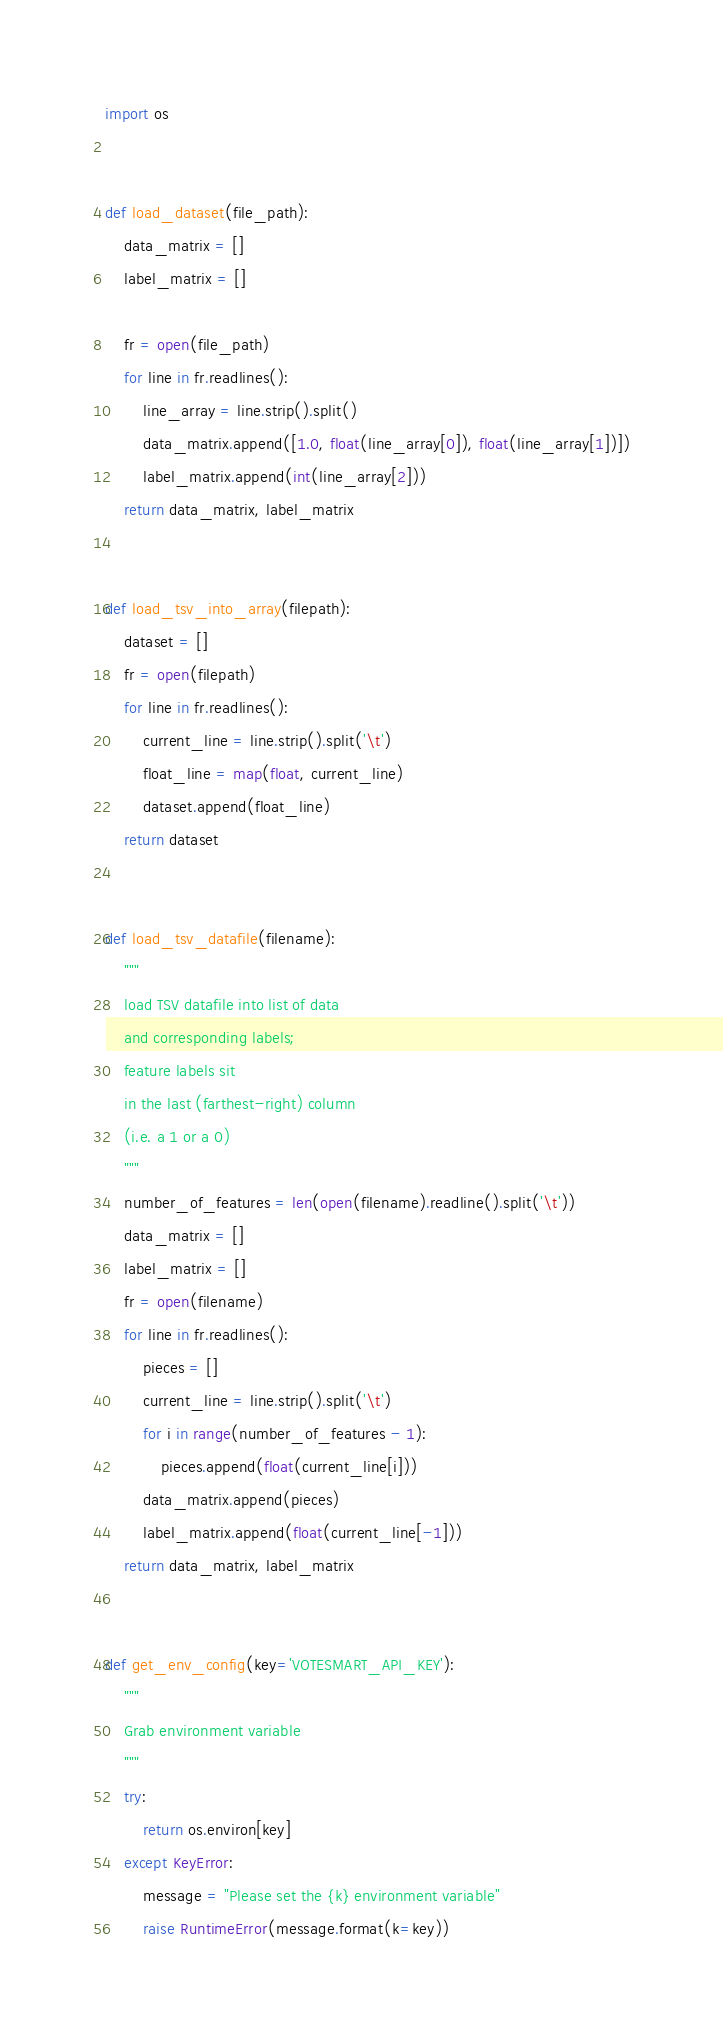Convert code to text. <code><loc_0><loc_0><loc_500><loc_500><_Python_>import os


def load_dataset(file_path):
    data_matrix = []
    label_matrix = []

    fr = open(file_path)
    for line in fr.readlines():
        line_array = line.strip().split()
        data_matrix.append([1.0, float(line_array[0]), float(line_array[1])])
        label_matrix.append(int(line_array[2]))
    return data_matrix, label_matrix


def load_tsv_into_array(filepath):
    dataset = []
    fr = open(filepath)
    for line in fr.readlines():
        current_line = line.strip().split('\t')
        float_line = map(float, current_line)
        dataset.append(float_line)
    return dataset


def load_tsv_datafile(filename):
    """
    load TSV datafile into list of data
    and corresponding labels;
    feature labels sit
    in the last (farthest-right) column
    (i.e. a 1 or a 0)
    """
    number_of_features = len(open(filename).readline().split('\t'))
    data_matrix = []
    label_matrix = []
    fr = open(filename)
    for line in fr.readlines():
        pieces = []
        current_line = line.strip().split('\t')
        for i in range(number_of_features - 1):
            pieces.append(float(current_line[i]))
        data_matrix.append(pieces)
        label_matrix.append(float(current_line[-1]))
    return data_matrix, label_matrix


def get_env_config(key='VOTESMART_API_KEY'):
    """
    Grab environment variable
    """
    try:
        return os.environ[key]
    except KeyError:
        message = "Please set the {k} environment variable"
        raise RuntimeError(message.format(k=key))
</code> 